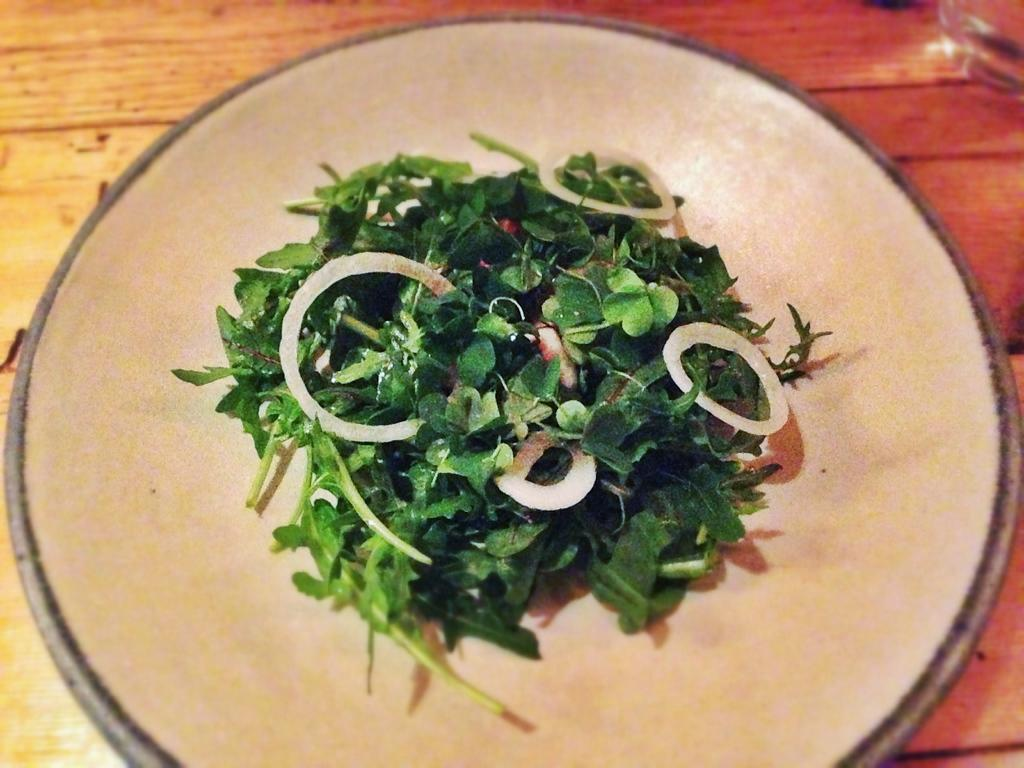What is on the plate that is visible in the image? There are leaves and onion slices on the plate in the image. Where is the plate located in the image? The plate is on a table at the bottom of the image. What type of yarn is being sold at the shop in the image? There is no shop or yarn present in the image; it only features a plate with leaves and onion slices on a table. 